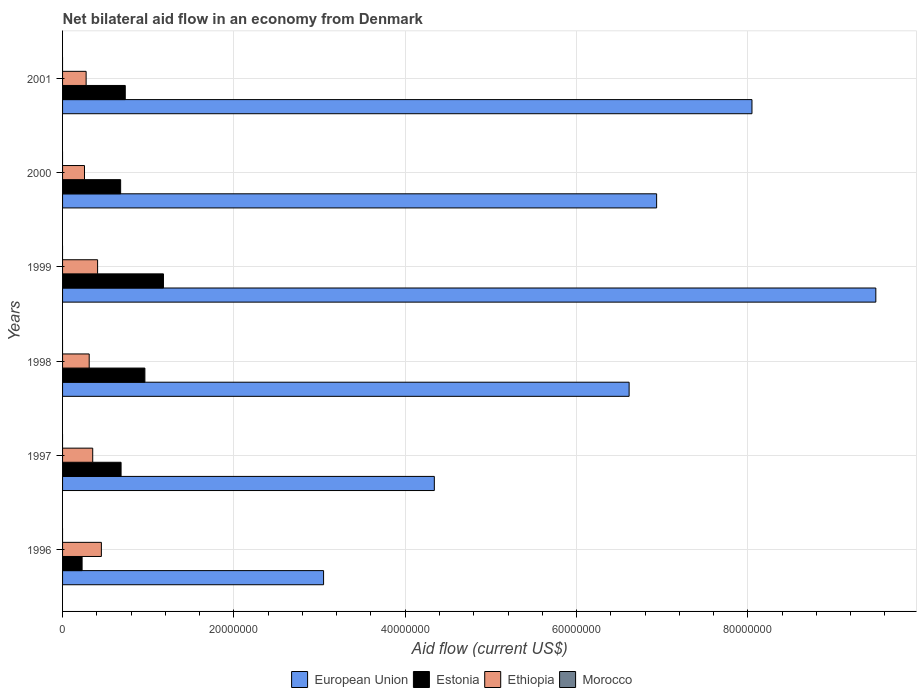Are the number of bars per tick equal to the number of legend labels?
Your response must be concise. No. Are the number of bars on each tick of the Y-axis equal?
Your answer should be compact. Yes. How many bars are there on the 1st tick from the bottom?
Your answer should be very brief. 3. What is the label of the 1st group of bars from the top?
Your answer should be very brief. 2001. In how many cases, is the number of bars for a given year not equal to the number of legend labels?
Provide a short and direct response. 6. What is the net bilateral aid flow in Estonia in 1998?
Offer a very short reply. 9.61e+06. Across all years, what is the maximum net bilateral aid flow in European Union?
Provide a succinct answer. 9.49e+07. Across all years, what is the minimum net bilateral aid flow in Morocco?
Offer a very short reply. 0. What is the total net bilateral aid flow in European Union in the graph?
Give a very brief answer. 3.85e+08. What is the difference between the net bilateral aid flow in Estonia in 1998 and that in 2000?
Your answer should be very brief. 2.83e+06. What is the difference between the net bilateral aid flow in Ethiopia in 1998 and the net bilateral aid flow in Morocco in 1997?
Provide a short and direct response. 3.11e+06. What is the average net bilateral aid flow in European Union per year?
Your response must be concise. 6.41e+07. In the year 1997, what is the difference between the net bilateral aid flow in European Union and net bilateral aid flow in Estonia?
Offer a terse response. 3.66e+07. In how many years, is the net bilateral aid flow in Ethiopia greater than 8000000 US$?
Your response must be concise. 0. What is the ratio of the net bilateral aid flow in Estonia in 1998 to that in 1999?
Your response must be concise. 0.82. What is the difference between the highest and the second highest net bilateral aid flow in Ethiopia?
Your response must be concise. 4.40e+05. What is the difference between the highest and the lowest net bilateral aid flow in Estonia?
Ensure brevity in your answer.  9.50e+06. In how many years, is the net bilateral aid flow in Ethiopia greater than the average net bilateral aid flow in Ethiopia taken over all years?
Your answer should be compact. 3. Is it the case that in every year, the sum of the net bilateral aid flow in Ethiopia and net bilateral aid flow in Morocco is greater than the sum of net bilateral aid flow in Estonia and net bilateral aid flow in European Union?
Ensure brevity in your answer.  No. How many years are there in the graph?
Make the answer very short. 6. What is the difference between two consecutive major ticks on the X-axis?
Your answer should be very brief. 2.00e+07. Are the values on the major ticks of X-axis written in scientific E-notation?
Your answer should be compact. No. Does the graph contain any zero values?
Provide a short and direct response. Yes. Does the graph contain grids?
Provide a succinct answer. Yes. Where does the legend appear in the graph?
Give a very brief answer. Bottom center. How are the legend labels stacked?
Provide a short and direct response. Horizontal. What is the title of the graph?
Keep it short and to the point. Net bilateral aid flow in an economy from Denmark. Does "Euro area" appear as one of the legend labels in the graph?
Give a very brief answer. No. What is the label or title of the X-axis?
Your response must be concise. Aid flow (current US$). What is the label or title of the Y-axis?
Your response must be concise. Years. What is the Aid flow (current US$) in European Union in 1996?
Provide a succinct answer. 3.05e+07. What is the Aid flow (current US$) in Estonia in 1996?
Your answer should be compact. 2.28e+06. What is the Aid flow (current US$) in Ethiopia in 1996?
Give a very brief answer. 4.53e+06. What is the Aid flow (current US$) in Morocco in 1996?
Provide a succinct answer. 0. What is the Aid flow (current US$) in European Union in 1997?
Give a very brief answer. 4.34e+07. What is the Aid flow (current US$) in Estonia in 1997?
Provide a short and direct response. 6.83e+06. What is the Aid flow (current US$) in Ethiopia in 1997?
Your response must be concise. 3.52e+06. What is the Aid flow (current US$) in Morocco in 1997?
Your response must be concise. 0. What is the Aid flow (current US$) in European Union in 1998?
Provide a succinct answer. 6.61e+07. What is the Aid flow (current US$) in Estonia in 1998?
Ensure brevity in your answer.  9.61e+06. What is the Aid flow (current US$) of Ethiopia in 1998?
Your response must be concise. 3.11e+06. What is the Aid flow (current US$) in Morocco in 1998?
Provide a succinct answer. 0. What is the Aid flow (current US$) of European Union in 1999?
Give a very brief answer. 9.49e+07. What is the Aid flow (current US$) of Estonia in 1999?
Keep it short and to the point. 1.18e+07. What is the Aid flow (current US$) of Ethiopia in 1999?
Give a very brief answer. 4.09e+06. What is the Aid flow (current US$) of European Union in 2000?
Your response must be concise. 6.94e+07. What is the Aid flow (current US$) in Estonia in 2000?
Your answer should be compact. 6.78e+06. What is the Aid flow (current US$) of Ethiopia in 2000?
Make the answer very short. 2.56e+06. What is the Aid flow (current US$) of Morocco in 2000?
Offer a very short reply. 0. What is the Aid flow (current US$) in European Union in 2001?
Offer a very short reply. 8.05e+07. What is the Aid flow (current US$) in Estonia in 2001?
Your answer should be very brief. 7.32e+06. What is the Aid flow (current US$) in Ethiopia in 2001?
Your answer should be compact. 2.75e+06. What is the Aid flow (current US$) of Morocco in 2001?
Offer a terse response. 0. Across all years, what is the maximum Aid flow (current US$) of European Union?
Provide a short and direct response. 9.49e+07. Across all years, what is the maximum Aid flow (current US$) of Estonia?
Your answer should be very brief. 1.18e+07. Across all years, what is the maximum Aid flow (current US$) of Ethiopia?
Offer a very short reply. 4.53e+06. Across all years, what is the minimum Aid flow (current US$) of European Union?
Your response must be concise. 3.05e+07. Across all years, what is the minimum Aid flow (current US$) of Estonia?
Your response must be concise. 2.28e+06. Across all years, what is the minimum Aid flow (current US$) of Ethiopia?
Give a very brief answer. 2.56e+06. What is the total Aid flow (current US$) in European Union in the graph?
Provide a succinct answer. 3.85e+08. What is the total Aid flow (current US$) in Estonia in the graph?
Provide a short and direct response. 4.46e+07. What is the total Aid flow (current US$) of Ethiopia in the graph?
Your answer should be compact. 2.06e+07. What is the difference between the Aid flow (current US$) in European Union in 1996 and that in 1997?
Keep it short and to the point. -1.29e+07. What is the difference between the Aid flow (current US$) of Estonia in 1996 and that in 1997?
Your answer should be compact. -4.55e+06. What is the difference between the Aid flow (current US$) in Ethiopia in 1996 and that in 1997?
Offer a very short reply. 1.01e+06. What is the difference between the Aid flow (current US$) in European Union in 1996 and that in 1998?
Make the answer very short. -3.57e+07. What is the difference between the Aid flow (current US$) of Estonia in 1996 and that in 1998?
Ensure brevity in your answer.  -7.33e+06. What is the difference between the Aid flow (current US$) in Ethiopia in 1996 and that in 1998?
Keep it short and to the point. 1.42e+06. What is the difference between the Aid flow (current US$) in European Union in 1996 and that in 1999?
Keep it short and to the point. -6.45e+07. What is the difference between the Aid flow (current US$) in Estonia in 1996 and that in 1999?
Offer a terse response. -9.50e+06. What is the difference between the Aid flow (current US$) of Ethiopia in 1996 and that in 1999?
Provide a succinct answer. 4.40e+05. What is the difference between the Aid flow (current US$) of European Union in 1996 and that in 2000?
Keep it short and to the point. -3.89e+07. What is the difference between the Aid flow (current US$) of Estonia in 1996 and that in 2000?
Give a very brief answer. -4.50e+06. What is the difference between the Aid flow (current US$) in Ethiopia in 1996 and that in 2000?
Provide a succinct answer. 1.97e+06. What is the difference between the Aid flow (current US$) of European Union in 1996 and that in 2001?
Ensure brevity in your answer.  -5.00e+07. What is the difference between the Aid flow (current US$) in Estonia in 1996 and that in 2001?
Give a very brief answer. -5.04e+06. What is the difference between the Aid flow (current US$) of Ethiopia in 1996 and that in 2001?
Your answer should be very brief. 1.78e+06. What is the difference between the Aid flow (current US$) of European Union in 1997 and that in 1998?
Offer a terse response. -2.27e+07. What is the difference between the Aid flow (current US$) in Estonia in 1997 and that in 1998?
Provide a short and direct response. -2.78e+06. What is the difference between the Aid flow (current US$) in Ethiopia in 1997 and that in 1998?
Your answer should be compact. 4.10e+05. What is the difference between the Aid flow (current US$) of European Union in 1997 and that in 1999?
Your answer should be very brief. -5.15e+07. What is the difference between the Aid flow (current US$) of Estonia in 1997 and that in 1999?
Offer a terse response. -4.95e+06. What is the difference between the Aid flow (current US$) of Ethiopia in 1997 and that in 1999?
Offer a terse response. -5.70e+05. What is the difference between the Aid flow (current US$) of European Union in 1997 and that in 2000?
Provide a succinct answer. -2.60e+07. What is the difference between the Aid flow (current US$) in Ethiopia in 1997 and that in 2000?
Offer a very short reply. 9.60e+05. What is the difference between the Aid flow (current US$) of European Union in 1997 and that in 2001?
Give a very brief answer. -3.71e+07. What is the difference between the Aid flow (current US$) of Estonia in 1997 and that in 2001?
Keep it short and to the point. -4.90e+05. What is the difference between the Aid flow (current US$) in Ethiopia in 1997 and that in 2001?
Make the answer very short. 7.70e+05. What is the difference between the Aid flow (current US$) in European Union in 1998 and that in 1999?
Provide a short and direct response. -2.88e+07. What is the difference between the Aid flow (current US$) in Estonia in 1998 and that in 1999?
Ensure brevity in your answer.  -2.17e+06. What is the difference between the Aid flow (current US$) in Ethiopia in 1998 and that in 1999?
Provide a succinct answer. -9.80e+05. What is the difference between the Aid flow (current US$) of European Union in 1998 and that in 2000?
Your answer should be very brief. -3.21e+06. What is the difference between the Aid flow (current US$) of Estonia in 1998 and that in 2000?
Offer a very short reply. 2.83e+06. What is the difference between the Aid flow (current US$) in European Union in 1998 and that in 2001?
Provide a short and direct response. -1.43e+07. What is the difference between the Aid flow (current US$) in Estonia in 1998 and that in 2001?
Offer a terse response. 2.29e+06. What is the difference between the Aid flow (current US$) in Ethiopia in 1998 and that in 2001?
Your answer should be very brief. 3.60e+05. What is the difference between the Aid flow (current US$) in European Union in 1999 and that in 2000?
Make the answer very short. 2.56e+07. What is the difference between the Aid flow (current US$) of Ethiopia in 1999 and that in 2000?
Ensure brevity in your answer.  1.53e+06. What is the difference between the Aid flow (current US$) in European Union in 1999 and that in 2001?
Your response must be concise. 1.45e+07. What is the difference between the Aid flow (current US$) of Estonia in 1999 and that in 2001?
Provide a succinct answer. 4.46e+06. What is the difference between the Aid flow (current US$) of Ethiopia in 1999 and that in 2001?
Offer a very short reply. 1.34e+06. What is the difference between the Aid flow (current US$) of European Union in 2000 and that in 2001?
Offer a very short reply. -1.11e+07. What is the difference between the Aid flow (current US$) of Estonia in 2000 and that in 2001?
Keep it short and to the point. -5.40e+05. What is the difference between the Aid flow (current US$) of European Union in 1996 and the Aid flow (current US$) of Estonia in 1997?
Give a very brief answer. 2.36e+07. What is the difference between the Aid flow (current US$) of European Union in 1996 and the Aid flow (current US$) of Ethiopia in 1997?
Keep it short and to the point. 2.70e+07. What is the difference between the Aid flow (current US$) of Estonia in 1996 and the Aid flow (current US$) of Ethiopia in 1997?
Offer a terse response. -1.24e+06. What is the difference between the Aid flow (current US$) in European Union in 1996 and the Aid flow (current US$) in Estonia in 1998?
Your answer should be compact. 2.09e+07. What is the difference between the Aid flow (current US$) of European Union in 1996 and the Aid flow (current US$) of Ethiopia in 1998?
Ensure brevity in your answer.  2.74e+07. What is the difference between the Aid flow (current US$) in Estonia in 1996 and the Aid flow (current US$) in Ethiopia in 1998?
Give a very brief answer. -8.30e+05. What is the difference between the Aid flow (current US$) of European Union in 1996 and the Aid flow (current US$) of Estonia in 1999?
Ensure brevity in your answer.  1.87e+07. What is the difference between the Aid flow (current US$) in European Union in 1996 and the Aid flow (current US$) in Ethiopia in 1999?
Your response must be concise. 2.64e+07. What is the difference between the Aid flow (current US$) in Estonia in 1996 and the Aid flow (current US$) in Ethiopia in 1999?
Provide a succinct answer. -1.81e+06. What is the difference between the Aid flow (current US$) in European Union in 1996 and the Aid flow (current US$) in Estonia in 2000?
Provide a succinct answer. 2.37e+07. What is the difference between the Aid flow (current US$) in European Union in 1996 and the Aid flow (current US$) in Ethiopia in 2000?
Your answer should be compact. 2.79e+07. What is the difference between the Aid flow (current US$) in Estonia in 1996 and the Aid flow (current US$) in Ethiopia in 2000?
Offer a terse response. -2.80e+05. What is the difference between the Aid flow (current US$) in European Union in 1996 and the Aid flow (current US$) in Estonia in 2001?
Your answer should be very brief. 2.32e+07. What is the difference between the Aid flow (current US$) in European Union in 1996 and the Aid flow (current US$) in Ethiopia in 2001?
Offer a very short reply. 2.77e+07. What is the difference between the Aid flow (current US$) in Estonia in 1996 and the Aid flow (current US$) in Ethiopia in 2001?
Give a very brief answer. -4.70e+05. What is the difference between the Aid flow (current US$) of European Union in 1997 and the Aid flow (current US$) of Estonia in 1998?
Your answer should be very brief. 3.38e+07. What is the difference between the Aid flow (current US$) in European Union in 1997 and the Aid flow (current US$) in Ethiopia in 1998?
Offer a terse response. 4.03e+07. What is the difference between the Aid flow (current US$) in Estonia in 1997 and the Aid flow (current US$) in Ethiopia in 1998?
Your response must be concise. 3.72e+06. What is the difference between the Aid flow (current US$) in European Union in 1997 and the Aid flow (current US$) in Estonia in 1999?
Offer a terse response. 3.16e+07. What is the difference between the Aid flow (current US$) of European Union in 1997 and the Aid flow (current US$) of Ethiopia in 1999?
Provide a short and direct response. 3.93e+07. What is the difference between the Aid flow (current US$) of Estonia in 1997 and the Aid flow (current US$) of Ethiopia in 1999?
Ensure brevity in your answer.  2.74e+06. What is the difference between the Aid flow (current US$) in European Union in 1997 and the Aid flow (current US$) in Estonia in 2000?
Offer a terse response. 3.66e+07. What is the difference between the Aid flow (current US$) in European Union in 1997 and the Aid flow (current US$) in Ethiopia in 2000?
Provide a succinct answer. 4.08e+07. What is the difference between the Aid flow (current US$) in Estonia in 1997 and the Aid flow (current US$) in Ethiopia in 2000?
Offer a terse response. 4.27e+06. What is the difference between the Aid flow (current US$) in European Union in 1997 and the Aid flow (current US$) in Estonia in 2001?
Provide a succinct answer. 3.61e+07. What is the difference between the Aid flow (current US$) in European Union in 1997 and the Aid flow (current US$) in Ethiopia in 2001?
Your answer should be very brief. 4.06e+07. What is the difference between the Aid flow (current US$) in Estonia in 1997 and the Aid flow (current US$) in Ethiopia in 2001?
Your answer should be very brief. 4.08e+06. What is the difference between the Aid flow (current US$) in European Union in 1998 and the Aid flow (current US$) in Estonia in 1999?
Offer a terse response. 5.44e+07. What is the difference between the Aid flow (current US$) in European Union in 1998 and the Aid flow (current US$) in Ethiopia in 1999?
Provide a short and direct response. 6.20e+07. What is the difference between the Aid flow (current US$) of Estonia in 1998 and the Aid flow (current US$) of Ethiopia in 1999?
Your response must be concise. 5.52e+06. What is the difference between the Aid flow (current US$) of European Union in 1998 and the Aid flow (current US$) of Estonia in 2000?
Your answer should be compact. 5.94e+07. What is the difference between the Aid flow (current US$) in European Union in 1998 and the Aid flow (current US$) in Ethiopia in 2000?
Provide a succinct answer. 6.36e+07. What is the difference between the Aid flow (current US$) in Estonia in 1998 and the Aid flow (current US$) in Ethiopia in 2000?
Offer a very short reply. 7.05e+06. What is the difference between the Aid flow (current US$) in European Union in 1998 and the Aid flow (current US$) in Estonia in 2001?
Make the answer very short. 5.88e+07. What is the difference between the Aid flow (current US$) in European Union in 1998 and the Aid flow (current US$) in Ethiopia in 2001?
Your answer should be compact. 6.34e+07. What is the difference between the Aid flow (current US$) in Estonia in 1998 and the Aid flow (current US$) in Ethiopia in 2001?
Your answer should be very brief. 6.86e+06. What is the difference between the Aid flow (current US$) in European Union in 1999 and the Aid flow (current US$) in Estonia in 2000?
Offer a terse response. 8.82e+07. What is the difference between the Aid flow (current US$) in European Union in 1999 and the Aid flow (current US$) in Ethiopia in 2000?
Provide a short and direct response. 9.24e+07. What is the difference between the Aid flow (current US$) in Estonia in 1999 and the Aid flow (current US$) in Ethiopia in 2000?
Your answer should be compact. 9.22e+06. What is the difference between the Aid flow (current US$) of European Union in 1999 and the Aid flow (current US$) of Estonia in 2001?
Offer a terse response. 8.76e+07. What is the difference between the Aid flow (current US$) in European Union in 1999 and the Aid flow (current US$) in Ethiopia in 2001?
Make the answer very short. 9.22e+07. What is the difference between the Aid flow (current US$) in Estonia in 1999 and the Aid flow (current US$) in Ethiopia in 2001?
Make the answer very short. 9.03e+06. What is the difference between the Aid flow (current US$) of European Union in 2000 and the Aid flow (current US$) of Estonia in 2001?
Your answer should be compact. 6.20e+07. What is the difference between the Aid flow (current US$) in European Union in 2000 and the Aid flow (current US$) in Ethiopia in 2001?
Provide a succinct answer. 6.66e+07. What is the difference between the Aid flow (current US$) in Estonia in 2000 and the Aid flow (current US$) in Ethiopia in 2001?
Offer a very short reply. 4.03e+06. What is the average Aid flow (current US$) in European Union per year?
Make the answer very short. 6.41e+07. What is the average Aid flow (current US$) of Estonia per year?
Your answer should be compact. 7.43e+06. What is the average Aid flow (current US$) of Ethiopia per year?
Your answer should be very brief. 3.43e+06. What is the average Aid flow (current US$) in Morocco per year?
Provide a short and direct response. 0. In the year 1996, what is the difference between the Aid flow (current US$) of European Union and Aid flow (current US$) of Estonia?
Provide a succinct answer. 2.82e+07. In the year 1996, what is the difference between the Aid flow (current US$) in European Union and Aid flow (current US$) in Ethiopia?
Offer a very short reply. 2.59e+07. In the year 1996, what is the difference between the Aid flow (current US$) of Estonia and Aid flow (current US$) of Ethiopia?
Offer a terse response. -2.25e+06. In the year 1997, what is the difference between the Aid flow (current US$) of European Union and Aid flow (current US$) of Estonia?
Your answer should be compact. 3.66e+07. In the year 1997, what is the difference between the Aid flow (current US$) in European Union and Aid flow (current US$) in Ethiopia?
Your answer should be compact. 3.99e+07. In the year 1997, what is the difference between the Aid flow (current US$) of Estonia and Aid flow (current US$) of Ethiopia?
Offer a very short reply. 3.31e+06. In the year 1998, what is the difference between the Aid flow (current US$) in European Union and Aid flow (current US$) in Estonia?
Provide a short and direct response. 5.65e+07. In the year 1998, what is the difference between the Aid flow (current US$) in European Union and Aid flow (current US$) in Ethiopia?
Ensure brevity in your answer.  6.30e+07. In the year 1998, what is the difference between the Aid flow (current US$) in Estonia and Aid flow (current US$) in Ethiopia?
Offer a very short reply. 6.50e+06. In the year 1999, what is the difference between the Aid flow (current US$) in European Union and Aid flow (current US$) in Estonia?
Your response must be concise. 8.32e+07. In the year 1999, what is the difference between the Aid flow (current US$) of European Union and Aid flow (current US$) of Ethiopia?
Keep it short and to the point. 9.08e+07. In the year 1999, what is the difference between the Aid flow (current US$) in Estonia and Aid flow (current US$) in Ethiopia?
Offer a very short reply. 7.69e+06. In the year 2000, what is the difference between the Aid flow (current US$) of European Union and Aid flow (current US$) of Estonia?
Make the answer very short. 6.26e+07. In the year 2000, what is the difference between the Aid flow (current US$) of European Union and Aid flow (current US$) of Ethiopia?
Ensure brevity in your answer.  6.68e+07. In the year 2000, what is the difference between the Aid flow (current US$) in Estonia and Aid flow (current US$) in Ethiopia?
Offer a terse response. 4.22e+06. In the year 2001, what is the difference between the Aid flow (current US$) in European Union and Aid flow (current US$) in Estonia?
Provide a succinct answer. 7.32e+07. In the year 2001, what is the difference between the Aid flow (current US$) of European Union and Aid flow (current US$) of Ethiopia?
Provide a succinct answer. 7.77e+07. In the year 2001, what is the difference between the Aid flow (current US$) in Estonia and Aid flow (current US$) in Ethiopia?
Your response must be concise. 4.57e+06. What is the ratio of the Aid flow (current US$) in European Union in 1996 to that in 1997?
Keep it short and to the point. 0.7. What is the ratio of the Aid flow (current US$) of Estonia in 1996 to that in 1997?
Your answer should be very brief. 0.33. What is the ratio of the Aid flow (current US$) of Ethiopia in 1996 to that in 1997?
Offer a terse response. 1.29. What is the ratio of the Aid flow (current US$) of European Union in 1996 to that in 1998?
Your answer should be compact. 0.46. What is the ratio of the Aid flow (current US$) of Estonia in 1996 to that in 1998?
Offer a terse response. 0.24. What is the ratio of the Aid flow (current US$) in Ethiopia in 1996 to that in 1998?
Your answer should be compact. 1.46. What is the ratio of the Aid flow (current US$) in European Union in 1996 to that in 1999?
Your answer should be very brief. 0.32. What is the ratio of the Aid flow (current US$) of Estonia in 1996 to that in 1999?
Provide a short and direct response. 0.19. What is the ratio of the Aid flow (current US$) of Ethiopia in 1996 to that in 1999?
Your response must be concise. 1.11. What is the ratio of the Aid flow (current US$) in European Union in 1996 to that in 2000?
Your response must be concise. 0.44. What is the ratio of the Aid flow (current US$) in Estonia in 1996 to that in 2000?
Keep it short and to the point. 0.34. What is the ratio of the Aid flow (current US$) of Ethiopia in 1996 to that in 2000?
Provide a short and direct response. 1.77. What is the ratio of the Aid flow (current US$) of European Union in 1996 to that in 2001?
Ensure brevity in your answer.  0.38. What is the ratio of the Aid flow (current US$) of Estonia in 1996 to that in 2001?
Your response must be concise. 0.31. What is the ratio of the Aid flow (current US$) of Ethiopia in 1996 to that in 2001?
Provide a short and direct response. 1.65. What is the ratio of the Aid flow (current US$) of European Union in 1997 to that in 1998?
Offer a very short reply. 0.66. What is the ratio of the Aid flow (current US$) of Estonia in 1997 to that in 1998?
Your answer should be very brief. 0.71. What is the ratio of the Aid flow (current US$) in Ethiopia in 1997 to that in 1998?
Your response must be concise. 1.13. What is the ratio of the Aid flow (current US$) in European Union in 1997 to that in 1999?
Your response must be concise. 0.46. What is the ratio of the Aid flow (current US$) of Estonia in 1997 to that in 1999?
Keep it short and to the point. 0.58. What is the ratio of the Aid flow (current US$) of Ethiopia in 1997 to that in 1999?
Ensure brevity in your answer.  0.86. What is the ratio of the Aid flow (current US$) of European Union in 1997 to that in 2000?
Offer a very short reply. 0.63. What is the ratio of the Aid flow (current US$) of Estonia in 1997 to that in 2000?
Your answer should be very brief. 1.01. What is the ratio of the Aid flow (current US$) of Ethiopia in 1997 to that in 2000?
Your answer should be compact. 1.38. What is the ratio of the Aid flow (current US$) of European Union in 1997 to that in 2001?
Give a very brief answer. 0.54. What is the ratio of the Aid flow (current US$) in Estonia in 1997 to that in 2001?
Provide a short and direct response. 0.93. What is the ratio of the Aid flow (current US$) in Ethiopia in 1997 to that in 2001?
Offer a very short reply. 1.28. What is the ratio of the Aid flow (current US$) in European Union in 1998 to that in 1999?
Your answer should be very brief. 0.7. What is the ratio of the Aid flow (current US$) in Estonia in 1998 to that in 1999?
Offer a terse response. 0.82. What is the ratio of the Aid flow (current US$) in Ethiopia in 1998 to that in 1999?
Provide a short and direct response. 0.76. What is the ratio of the Aid flow (current US$) in European Union in 1998 to that in 2000?
Keep it short and to the point. 0.95. What is the ratio of the Aid flow (current US$) of Estonia in 1998 to that in 2000?
Your answer should be very brief. 1.42. What is the ratio of the Aid flow (current US$) in Ethiopia in 1998 to that in 2000?
Give a very brief answer. 1.21. What is the ratio of the Aid flow (current US$) of European Union in 1998 to that in 2001?
Your answer should be compact. 0.82. What is the ratio of the Aid flow (current US$) in Estonia in 1998 to that in 2001?
Your response must be concise. 1.31. What is the ratio of the Aid flow (current US$) of Ethiopia in 1998 to that in 2001?
Your response must be concise. 1.13. What is the ratio of the Aid flow (current US$) of European Union in 1999 to that in 2000?
Give a very brief answer. 1.37. What is the ratio of the Aid flow (current US$) of Estonia in 1999 to that in 2000?
Keep it short and to the point. 1.74. What is the ratio of the Aid flow (current US$) in Ethiopia in 1999 to that in 2000?
Offer a terse response. 1.6. What is the ratio of the Aid flow (current US$) in European Union in 1999 to that in 2001?
Your answer should be compact. 1.18. What is the ratio of the Aid flow (current US$) of Estonia in 1999 to that in 2001?
Provide a short and direct response. 1.61. What is the ratio of the Aid flow (current US$) of Ethiopia in 1999 to that in 2001?
Your response must be concise. 1.49. What is the ratio of the Aid flow (current US$) of European Union in 2000 to that in 2001?
Make the answer very short. 0.86. What is the ratio of the Aid flow (current US$) of Estonia in 2000 to that in 2001?
Offer a very short reply. 0.93. What is the ratio of the Aid flow (current US$) in Ethiopia in 2000 to that in 2001?
Keep it short and to the point. 0.93. What is the difference between the highest and the second highest Aid flow (current US$) of European Union?
Keep it short and to the point. 1.45e+07. What is the difference between the highest and the second highest Aid flow (current US$) of Estonia?
Your answer should be compact. 2.17e+06. What is the difference between the highest and the lowest Aid flow (current US$) in European Union?
Make the answer very short. 6.45e+07. What is the difference between the highest and the lowest Aid flow (current US$) in Estonia?
Offer a terse response. 9.50e+06. What is the difference between the highest and the lowest Aid flow (current US$) of Ethiopia?
Your answer should be compact. 1.97e+06. 